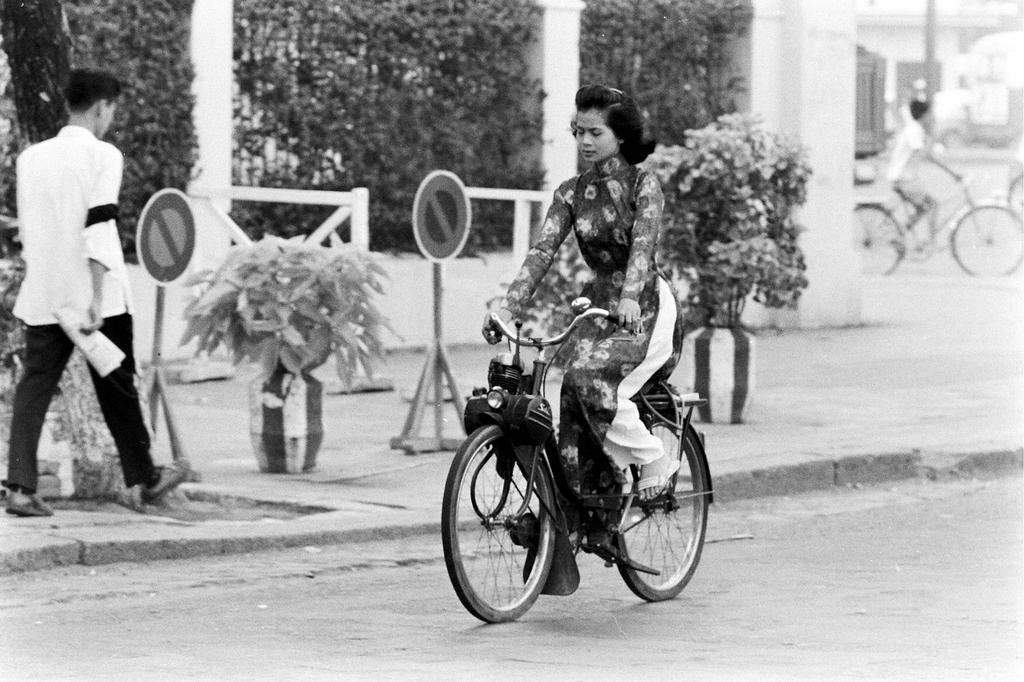How would you summarize this image in a sentence or two? In the picture we can find one woman is riding a bicycle and beside to it one man is walking on the path. In the background we can find some plants and trees. 